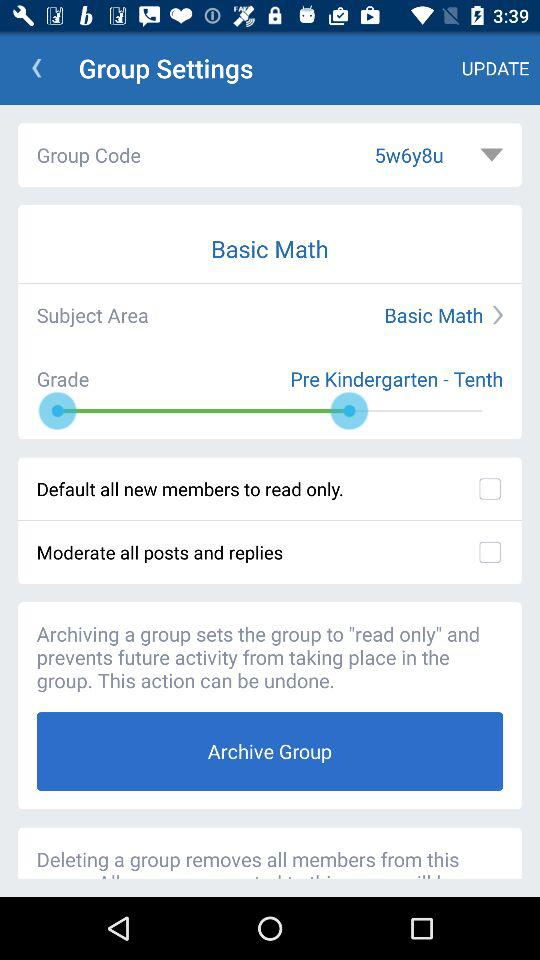What is the status of "Moderate all posts and replies"? The status is "off". 